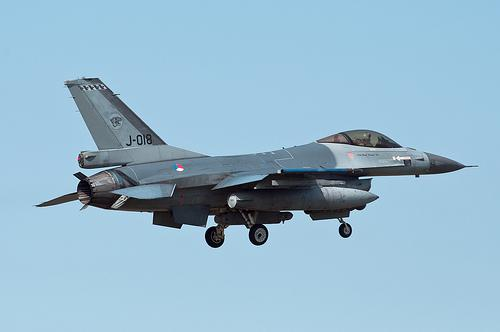Question: what is this a picture of?
Choices:
A. Cat.
B. Jet.
C. Dog.
D. Statue.
Answer with the letter. Answer: B Question: who is flying the plane?
Choices:
A. Pilot.
B. The co-pilot.
C. The auto-pilot.
D. A woman.
Answer with the letter. Answer: A Question: why is it light outside?
Choices:
A. It is morning.
B. Sun.
C. It is mid day.
D. It is the evening.
Answer with the letter. Answer: B Question: when was the picture taken?
Choices:
A. At night.
B. In the summer.
C. In the winter.
D. Morning.
Answer with the letter. Answer: D 